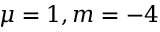Convert formula to latex. <formula><loc_0><loc_0><loc_500><loc_500>\mu = 1 , m = - 4</formula> 